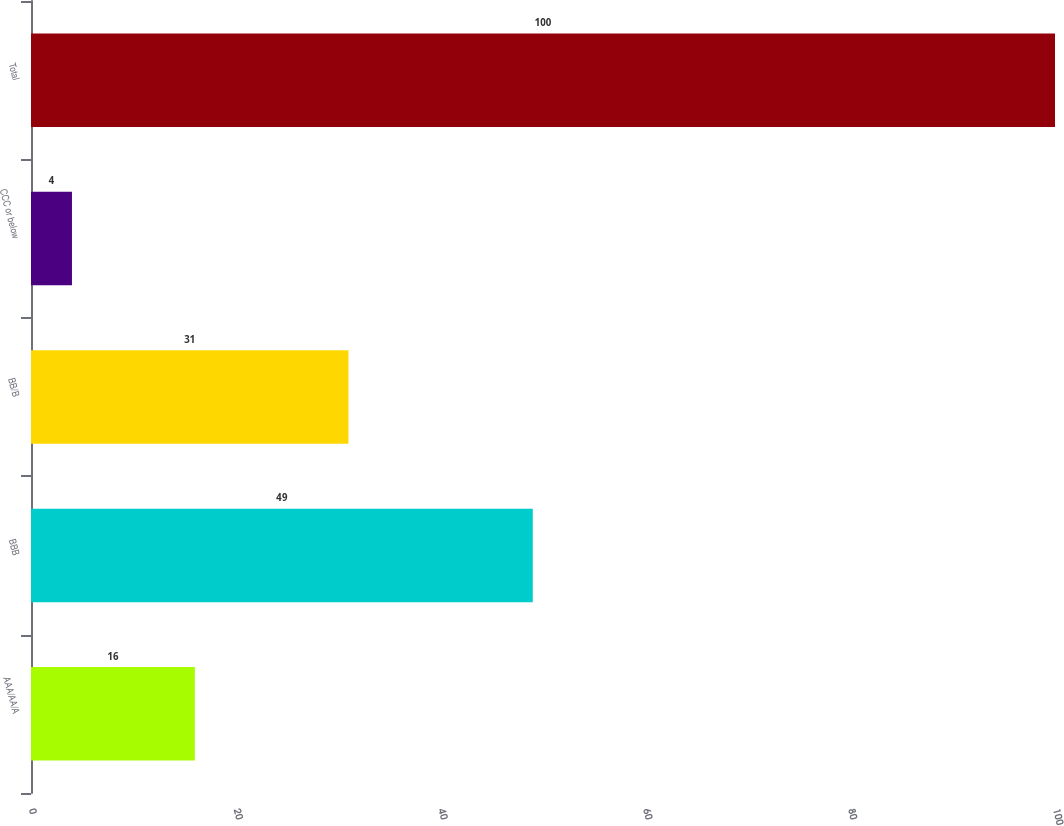<chart> <loc_0><loc_0><loc_500><loc_500><bar_chart><fcel>AAA/AA/A<fcel>BBB<fcel>BB/B<fcel>CCC or below<fcel>Total<nl><fcel>16<fcel>49<fcel>31<fcel>4<fcel>100<nl></chart> 